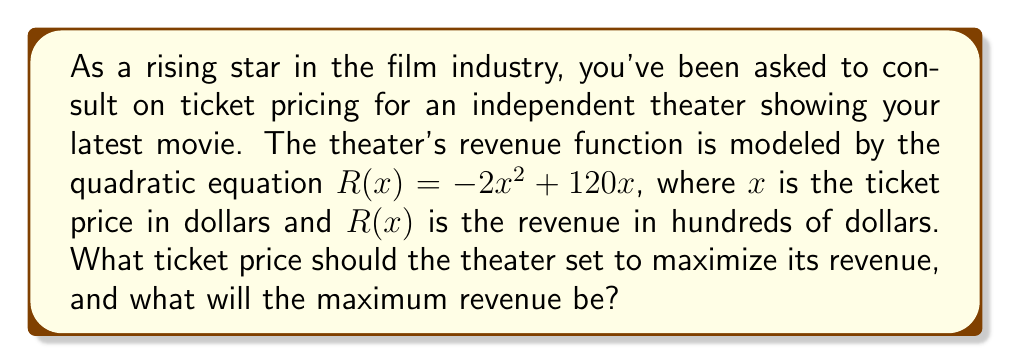Could you help me with this problem? To solve this problem, we'll follow these steps:

1) The revenue function is a quadratic equation in the form $R(x) = -2x^2 + 120x$. To find the maximum revenue, we need to find the vertex of this parabola.

2) For a quadratic function in the form $f(x) = ax^2 + bx + c$, the x-coordinate of the vertex is given by $x = -\frac{b}{2a}$.

3) In our case, $a = -2$ and $b = 120$. Let's substitute these values:

   $x = -\frac{120}{2(-2)} = -\frac{120}{-4} = 30$

4) This means the optimal ticket price is $30.

5) To find the maximum revenue, we need to substitute this x-value back into our original equation:

   $R(30) = -2(30)^2 + 120(30)$
   $= -2(900) + 3600$
   $= -1800 + 3600$
   $= 1800$

6) Remember that our revenue is in hundreds of dollars, so we need to multiply by 100.

Therefore, the maximum revenue is $1800 * 100 = $180,000.
Answer: The optimal ticket price is $30, and the maximum revenue is $180,000. 